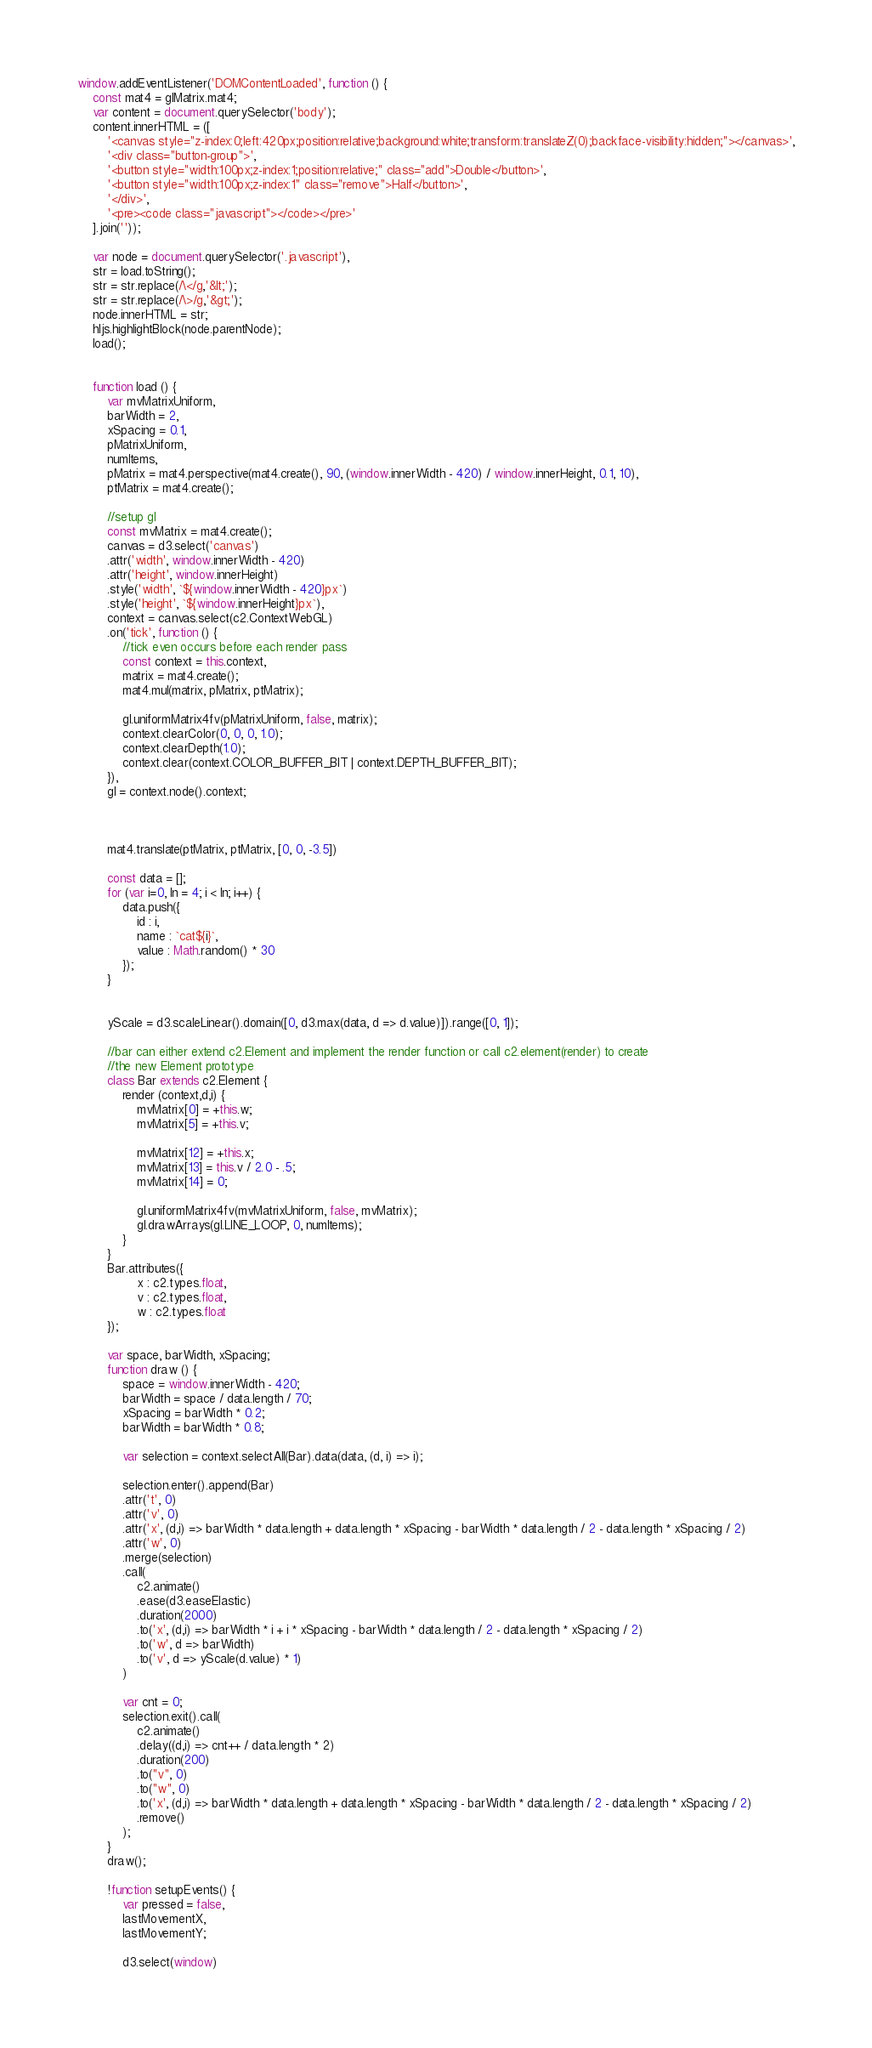Convert code to text. <code><loc_0><loc_0><loc_500><loc_500><_JavaScript_>window.addEventListener('DOMContentLoaded', function () {
    const mat4 = glMatrix.mat4;
    var content = document.querySelector('body');
    content.innerHTML = ([ 
        '<canvas style="z-index:0;left:420px;position:relative;background:white;transform:translateZ(0);backface-visibility:hidden;"></canvas>',
        '<div class="button-group">',
        '<button style="width:100px;z-index:1;position:relative;" class="add">Double</button>',
        '<button style="width:100px;z-index:1" class="remove">Half</button>',
        '</div>',
        '<pre><code class="javascript"></code></pre>'
    ].join(''));

    var node = document.querySelector('.javascript'),
    str = load.toString();
    str = str.replace(/\</g,'&lt;');
    str = str.replace(/\>/g,'&gt;');
    node.innerHTML = str;
    hljs.highlightBlock(node.parentNode);
    load();


    function load () {
        var mvMatrixUniform,
        barWidth = 2,
        xSpacing = 0.1,
        pMatrixUniform,
        numItems,
        pMatrix = mat4.perspective(mat4.create(), 90, (window.innerWidth - 420) / window.innerHeight, 0.1, 10),
        ptMatrix = mat4.create();

        //setup gl
        const mvMatrix = mat4.create();
        canvas = d3.select('canvas')
        .attr('width', window.innerWidth - 420)
        .attr('height', window.innerHeight)
        .style('width', `${window.innerWidth - 420}px`)
        .style('height', `${window.innerHeight}px`),
        context = canvas.select(c2.ContextWebGL)
        .on('tick', function () {
            //tick even occurs before each render pass
            const context = this.context,
            matrix = mat4.create();
            mat4.mul(matrix, pMatrix, ptMatrix);

            gl.uniformMatrix4fv(pMatrixUniform, false, matrix);
            context.clearColor(0, 0, 0, 1.0);
            context.clearDepth(1.0);
            context.clear(context.COLOR_BUFFER_BIT | context.DEPTH_BUFFER_BIT);
        }),
        gl = context.node().context;



        mat4.translate(ptMatrix, ptMatrix, [0, 0, -3.5])

        const data = [];
        for (var i=0, ln = 4; i < ln; i++) {
            data.push({
                id : i,
                name : `cat${i}`,
                value : Math.random() * 30
            });
        }


        yScale = d3.scaleLinear().domain([0, d3.max(data, d => d.value)]).range([0, 1]);

        //bar can either extend c2.Element and implement the render function or call c2.element(render) to create
        //the new Element prototype
        class Bar extends c2.Element {
            render (context,d,i) {
                mvMatrix[0] = +this.w; 
                mvMatrix[5] = +this.v;

                mvMatrix[12] = +this.x;
                mvMatrix[13] = this.v / 2.0 - .5;
                mvMatrix[14] = 0;

                gl.uniformMatrix4fv(mvMatrixUniform, false, mvMatrix);
                gl.drawArrays(gl.LINE_LOOP, 0, numItems);
            }
        }
        Bar.attributes({
                x : c2.types.float,
                v : c2.types.float,
                w : c2.types.float
        });

        var space, barWidth, xSpacing;
        function draw () {
            space = window.innerWidth - 420;
            barWidth = space / data.length / 70;
            xSpacing = barWidth * 0.2;
            barWidth = barWidth * 0.8;

            var selection = context.selectAll(Bar).data(data, (d, i) => i);

            selection.enter().append(Bar)
            .attr('t', 0)
            .attr('v', 0)
            .attr('x', (d,i) => barWidth * data.length + data.length * xSpacing - barWidth * data.length / 2 - data.length * xSpacing / 2)
            .attr('w', 0)
            .merge(selection)
            .call(
                c2.animate()
                .ease(d3.easeElastic)
                .duration(2000)
                .to('x', (d,i) => barWidth * i + i * xSpacing - barWidth * data.length / 2 - data.length * xSpacing / 2)
                .to('w', d => barWidth)
                .to('v', d => yScale(d.value) * 1)
            )

            var cnt = 0;
            selection.exit().call(
                c2.animate()
                .delay((d,i) => cnt++ / data.length * 2)
                .duration(200)
                .to("v", 0)
                .to("w", 0)
                .to('x', (d,i) => barWidth * data.length + data.length * xSpacing - barWidth * data.length / 2 - data.length * xSpacing / 2)
                .remove()
            );
        }
        draw();

        !function setupEvents() {
            var pressed = false,
            lastMovementX,
            lastMovementY;

            d3.select(window)</code> 